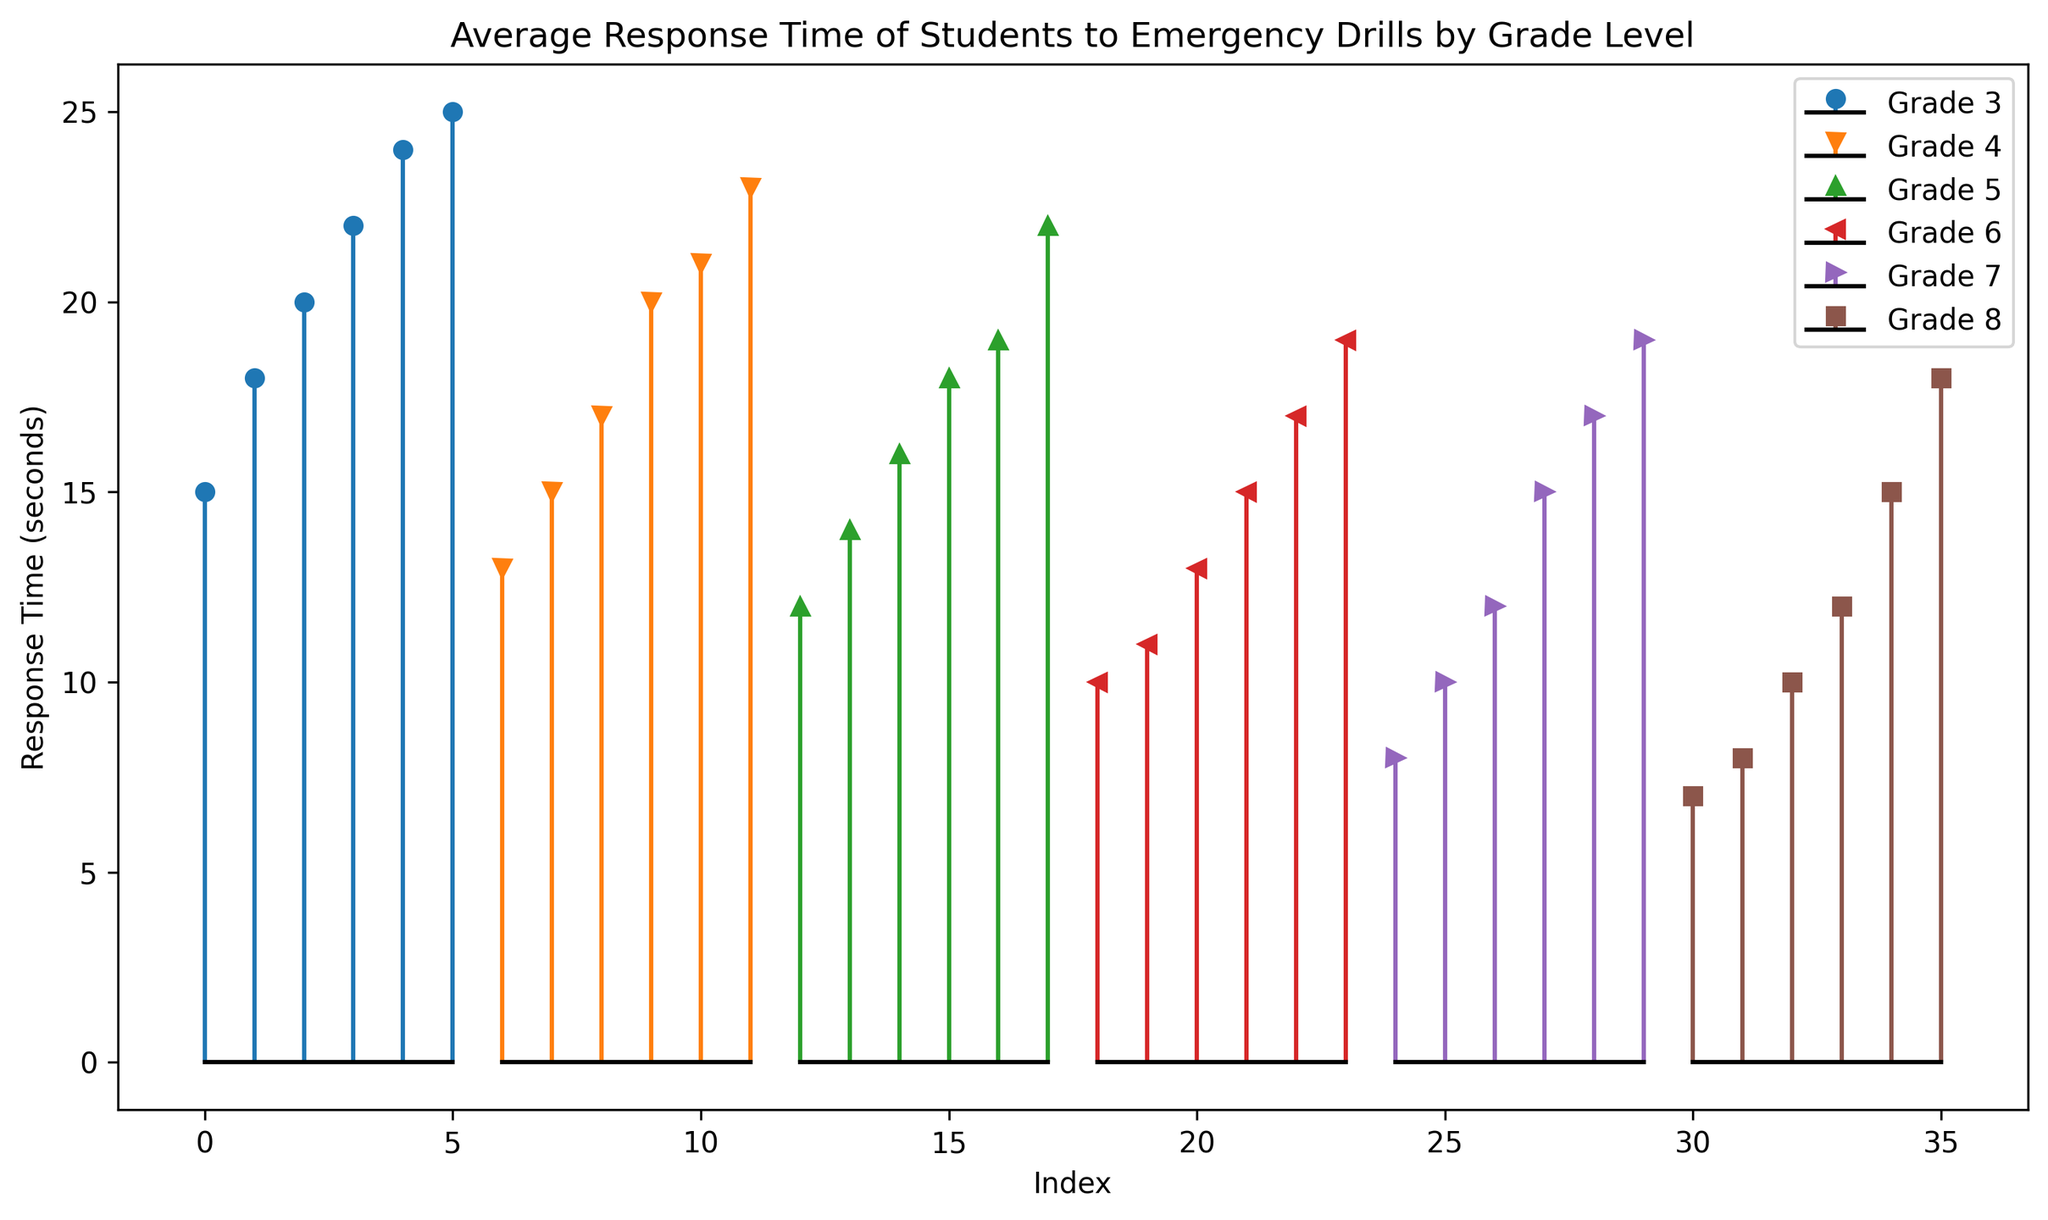What is the average response time for Grade 3? To find the average response time for Grade 3, sum all the response times (15 + 18 + 20 + 22 + 24 + 25) and divide by the number of data points (6). So, (124 / 6) = 20.67 seconds
Answer: 20.67 seconds Which grade level has the highest maximum response time? By visually inspecting the figure, you can see that Grade 3 has the highest maximum response time of 25 seconds, as no other grade level has a data point that exceeds this value.
Answer: Grade 3 How does the average response time of Grade 7 compare to Grade 8? First, calculate the average response time for both grades. For Grade 7: (8 + 10 + 12 + 15 + 17 + 19 = 81) / 6 = 13.5 seconds. For Grade 8: (7 + 8 + 10 + 12 + 15 + 18 = 70) / 6 = 11.67 seconds. Comparatively, 13.5 seconds is greater than 11.67 seconds.
Answer: Grade 7 is higher What is the range of response times for Grade 6? The range is the difference between the maximum and minimum response times. For Grade 6, the response times are from 10 to 19 seconds. So the range is 19 - 10 = 9 seconds.
Answer: 9 seconds How many response times are below 15 seconds for Grade 5? Visually, from the plot for Grade 5, you can see there are three data points below 15 seconds which are 12, 14, and 14.
Answer: 3 What is the median response time for Grade 4? To find the median, first list the response times in order: 13, 15, 17, 20, 21, 23. As there are 6 data points, the median is the average of the 3rd and 4th values: (17+20)/2 = 18.5 seconds.
Answer: 18.5 seconds Which grade level has the most stable response times, and what visual feature indicates this? Grade 8 has the most stable response times as they appear closely clustered together with less variation compared to other grades. This is visually indicated by less spread in their stem plot representation.
Answer: Grade 8 Which grade level has the greatest variability in response times, and why? Grade 3 has the greatest variability as the response times range from 15 to 25 seconds, which is visually indicated by a wide spread of points in their stem plot.
Answer: Grade 3 